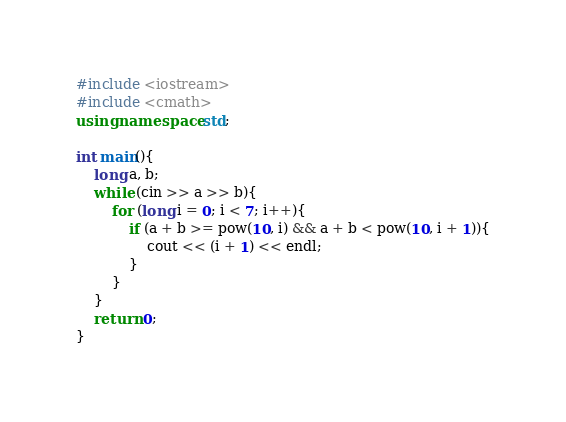<code> <loc_0><loc_0><loc_500><loc_500><_C++_>#include <iostream>
#include <cmath>
using namespace std;

int main(){
	long a, b;
	while (cin >> a >> b){
		for (long i = 0; i < 7; i++){
			if (a + b >= pow(10, i) && a + b < pow(10, i + 1)){
				cout << (i + 1) << endl;
			}
		}
	}
	return 0;
}</code> 